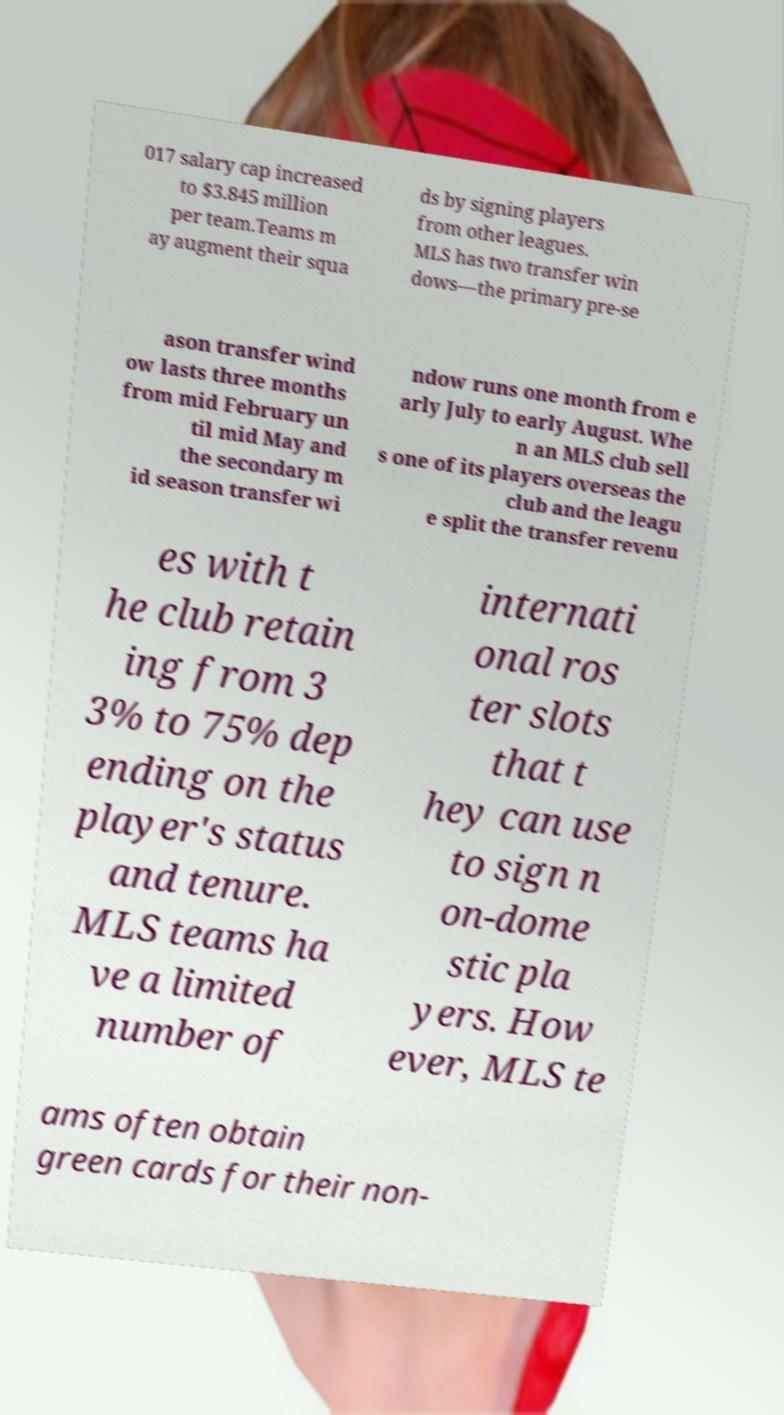For documentation purposes, I need the text within this image transcribed. Could you provide that? 017 salary cap increased to $3.845 million per team.Teams m ay augment their squa ds by signing players from other leagues. MLS has two transfer win dows—the primary pre-se ason transfer wind ow lasts three months from mid February un til mid May and the secondary m id season transfer wi ndow runs one month from e arly July to early August. Whe n an MLS club sell s one of its players overseas the club and the leagu e split the transfer revenu es with t he club retain ing from 3 3% to 75% dep ending on the player's status and tenure. MLS teams ha ve a limited number of internati onal ros ter slots that t hey can use to sign n on-dome stic pla yers. How ever, MLS te ams often obtain green cards for their non- 